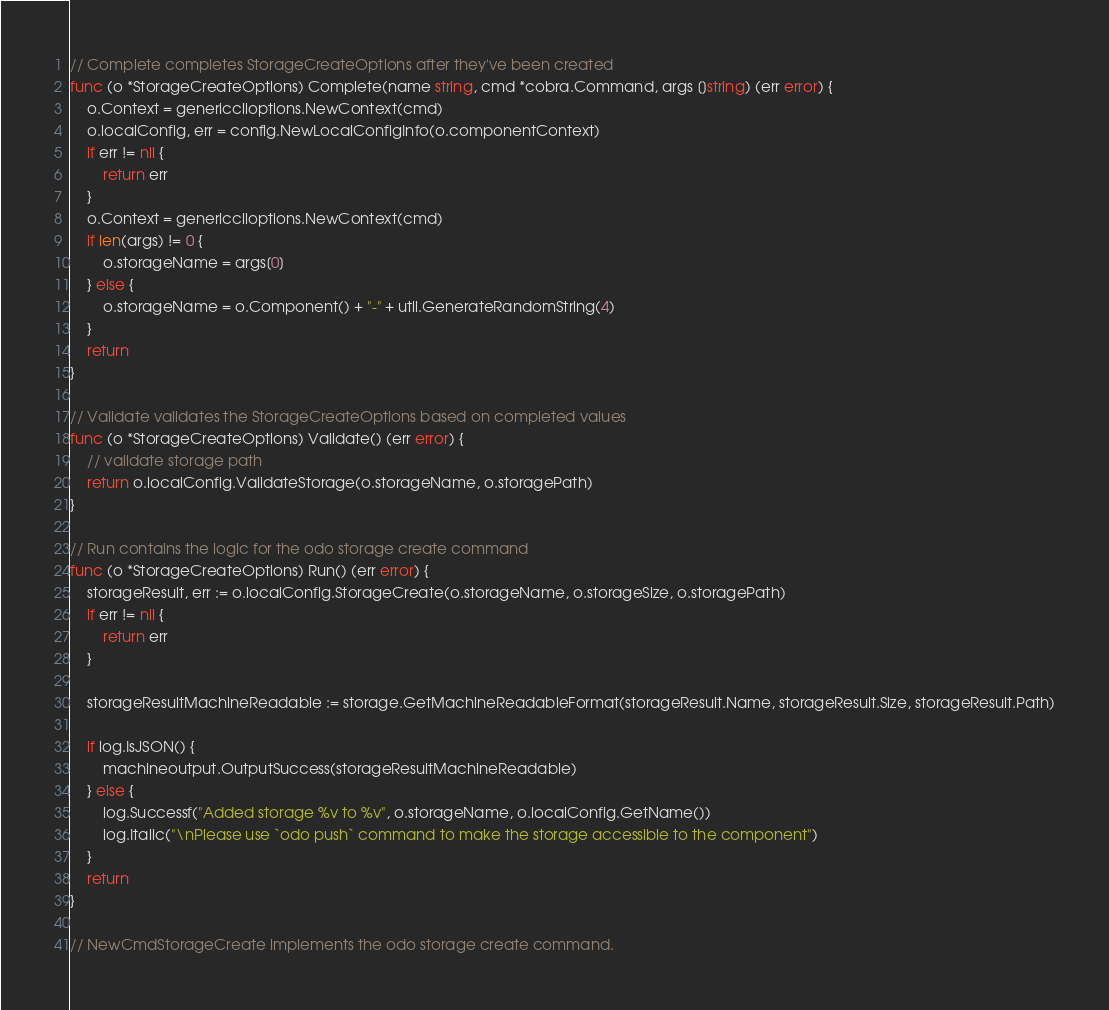Convert code to text. <code><loc_0><loc_0><loc_500><loc_500><_Go_>
// Complete completes StorageCreateOptions after they've been created
func (o *StorageCreateOptions) Complete(name string, cmd *cobra.Command, args []string) (err error) {
	o.Context = genericclioptions.NewContext(cmd)
	o.localConfig, err = config.NewLocalConfigInfo(o.componentContext)
	if err != nil {
		return err
	}
	o.Context = genericclioptions.NewContext(cmd)
	if len(args) != 0 {
		o.storageName = args[0]
	} else {
		o.storageName = o.Component() + "-" + util.GenerateRandomString(4)
	}
	return
}

// Validate validates the StorageCreateOptions based on completed values
func (o *StorageCreateOptions) Validate() (err error) {
	// validate storage path
	return o.localConfig.ValidateStorage(o.storageName, o.storagePath)
}

// Run contains the logic for the odo storage create command
func (o *StorageCreateOptions) Run() (err error) {
	storageResult, err := o.localConfig.StorageCreate(o.storageName, o.storageSize, o.storagePath)
	if err != nil {
		return err
	}

	storageResultMachineReadable := storage.GetMachineReadableFormat(storageResult.Name, storageResult.Size, storageResult.Path)

	if log.IsJSON() {
		machineoutput.OutputSuccess(storageResultMachineReadable)
	} else {
		log.Successf("Added storage %v to %v", o.storageName, o.localConfig.GetName())
		log.Italic("\nPlease use `odo push` command to make the storage accessible to the component")
	}
	return
}

// NewCmdStorageCreate implements the odo storage create command.</code> 